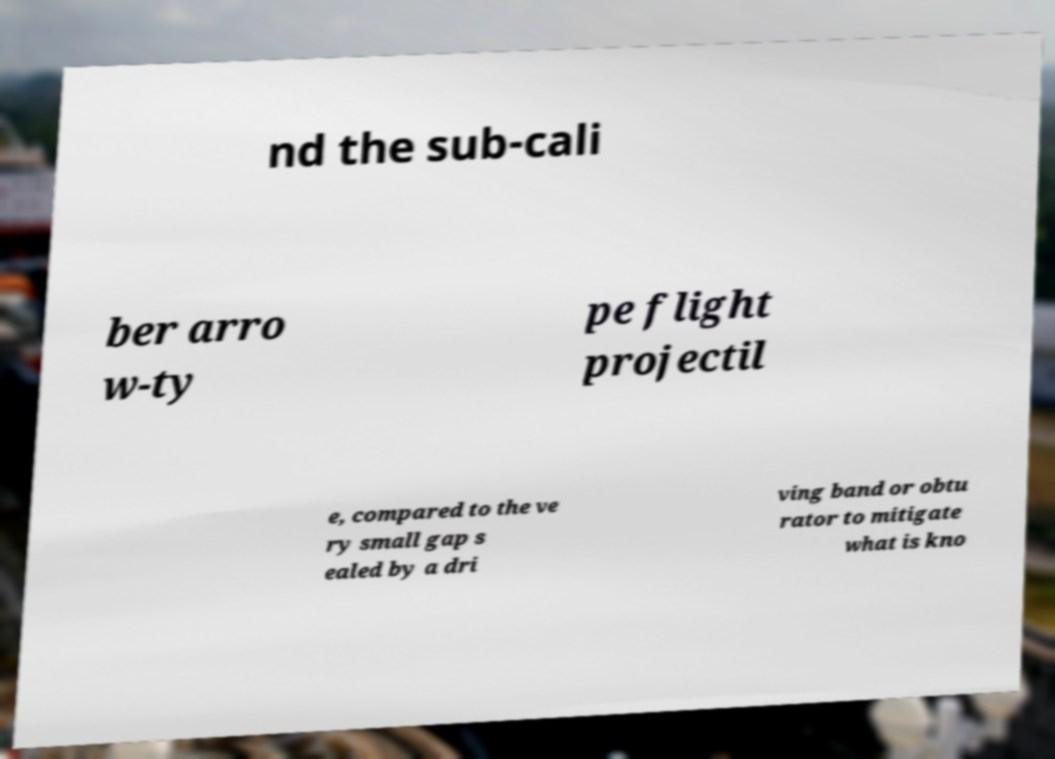For documentation purposes, I need the text within this image transcribed. Could you provide that? nd the sub-cali ber arro w-ty pe flight projectil e, compared to the ve ry small gap s ealed by a dri ving band or obtu rator to mitigate what is kno 